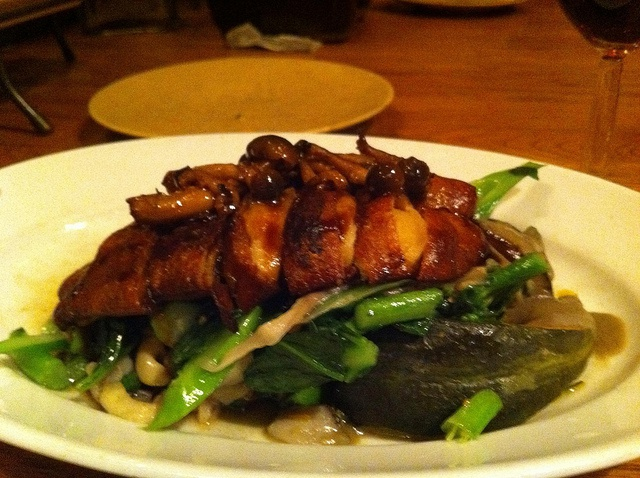Describe the objects in this image and their specific colors. I can see dining table in maroon, brown, and black tones, broccoli in maroon, black, darkgreen, and olive tones, wine glass in maroon, black, and brown tones, and broccoli in maroon, black, and darkgreen tones in this image. 